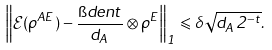<formula> <loc_0><loc_0><loc_500><loc_500>\left \| \mathcal { E } ( \rho ^ { A E } ) - \frac { \i d e n t } { d _ { A } } \otimes \rho ^ { E } \right \| _ { 1 } \leqslant \delta \sqrt { d _ { A } 2 ^ { - t } } .</formula> 